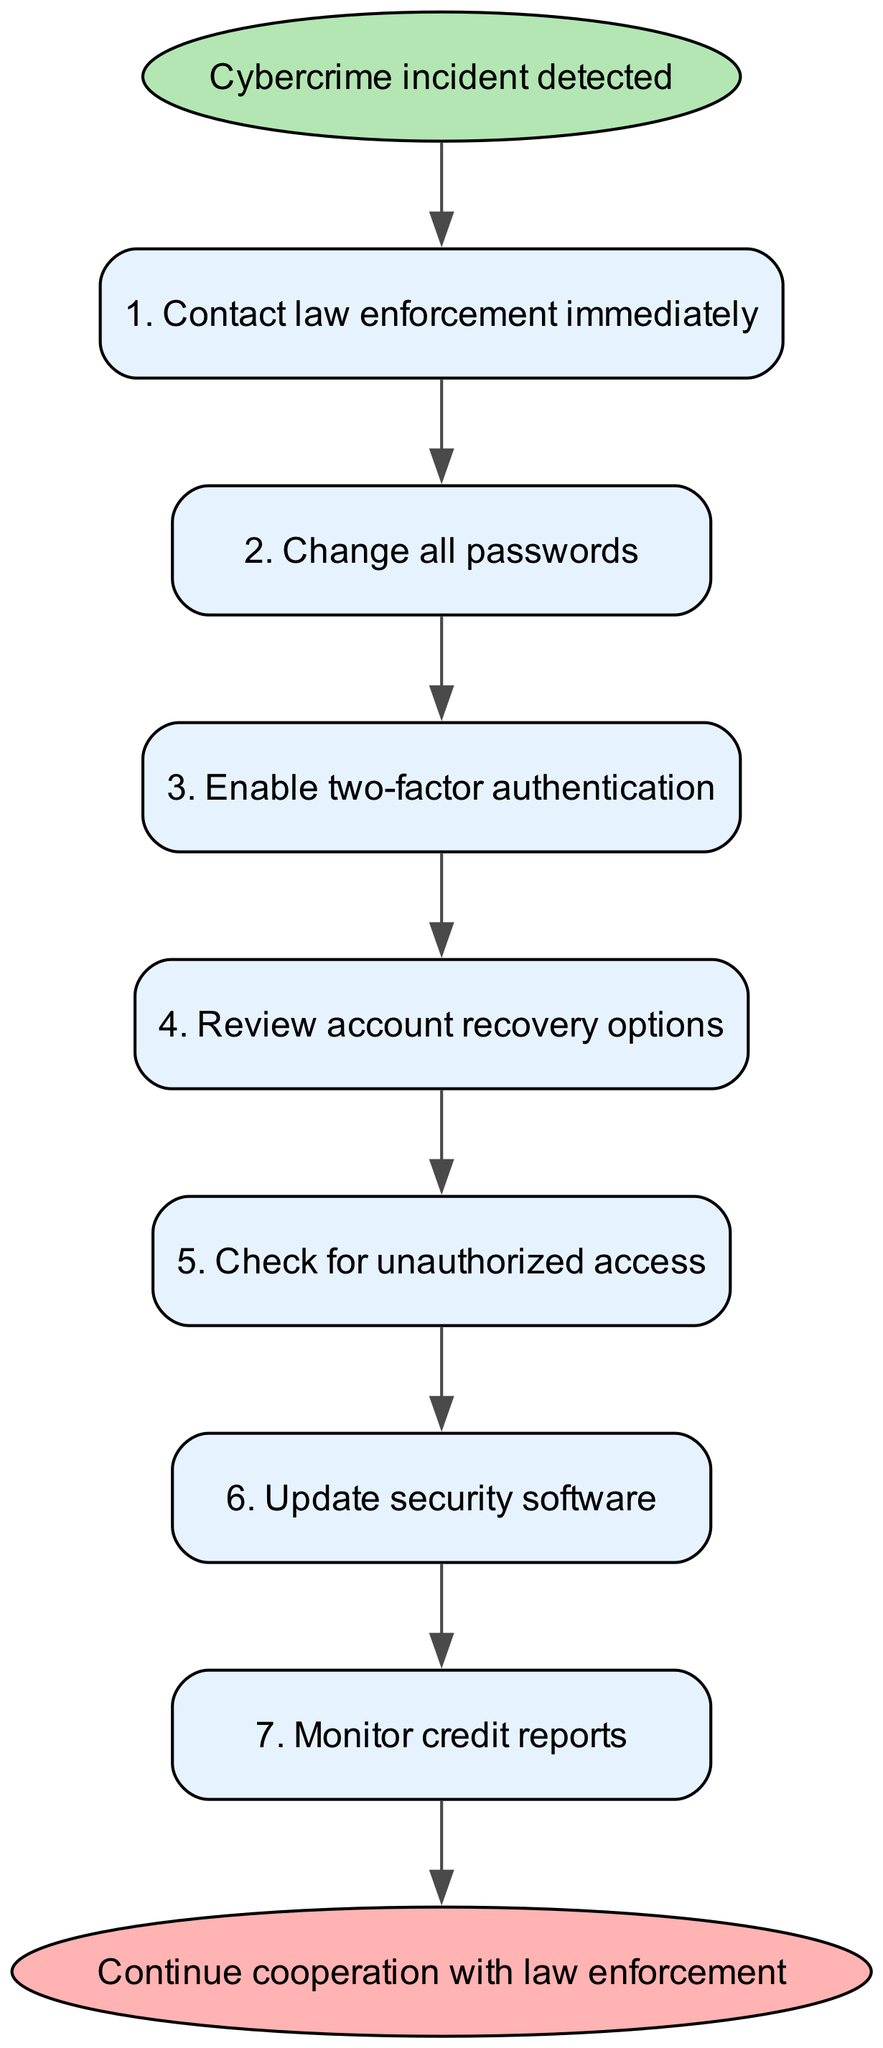What is the first step after detecting a cybercrime incident? The first step is represented by the initial node connected to the start node; it specifies "Contact law enforcement immediately."
Answer: Contact law enforcement immediately How many total steps are outlined in the diagram? The diagram contains seven individual steps that are sequentially connected from the start to the end node.
Answer: Seven What step involves enhancing account security? This involves "Enable two-factor authentication," which is clearly marked as step three in the sequence.
Answer: Enable two-factor authentication Which step immediately follows checking for unauthorized access? Reviewing account recovery options is the next step, which comes directly after checking for unauthorized access in the flow.
Answer: Review account recovery options What is the relationship between changing all passwords and enabling two-factor authentication? Changing all passwords is step two, and enabling two-factor authentication is step three, which means that the former needs to be completed before moving on to the latter in sequence.
Answer: Sequential Which step is preceded by updating security software? Monitoring credit reports follows the step of updating security software, indicating its place in the order of actions to take.
Answer: Monitor credit reports What is the last action indicated in the diagram? The final action is stated as "Continue cooperation with law enforcement," which is linked to the last step before reaching the end node.
Answer: Continue cooperation with law enforcement How many nodes represent steps in securing online accounts? There are seven nodes that specifically represent the steps needed for securing online accounts after the incident.
Answer: Seven What is the shape of the start node in the diagram? The shape of the start node is an ellipse, distinguishing it clearly from the rectangular nodes used for the steps.
Answer: Ellipse What color is associated with the end node? The end node is filled with a light red color, distinguishing it as the conclusion of the process represented in the diagram.
Answer: Light red 